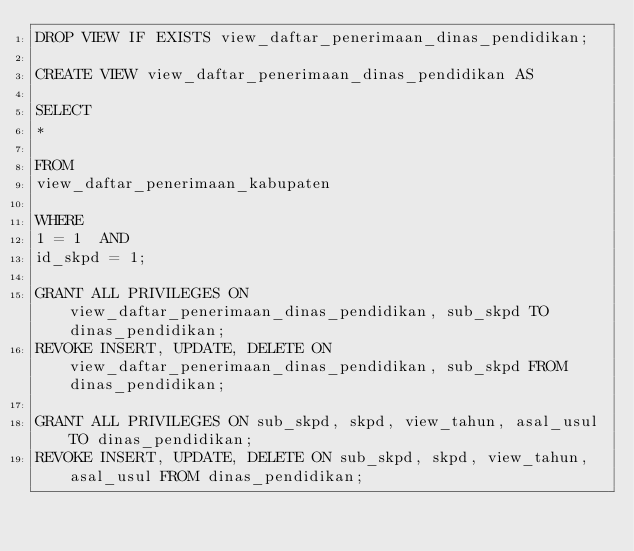<code> <loc_0><loc_0><loc_500><loc_500><_SQL_>DROP VIEW IF EXISTS view_daftar_penerimaan_dinas_pendidikan;

CREATE VIEW view_daftar_penerimaan_dinas_pendidikan AS

SELECT
*

FROM
view_daftar_penerimaan_kabupaten

WHERE
1 = 1  AND
id_skpd = 1;

GRANT ALL PRIVILEGES ON view_daftar_penerimaan_dinas_pendidikan, sub_skpd TO dinas_pendidikan;
REVOKE INSERT, UPDATE, DELETE ON view_daftar_penerimaan_dinas_pendidikan, sub_skpd FROM dinas_pendidikan;

GRANT ALL PRIVILEGES ON sub_skpd, skpd, view_tahun, asal_usul TO dinas_pendidikan;
REVOKE INSERT, UPDATE, DELETE ON sub_skpd, skpd, view_tahun, asal_usul FROM dinas_pendidikan;
</code> 